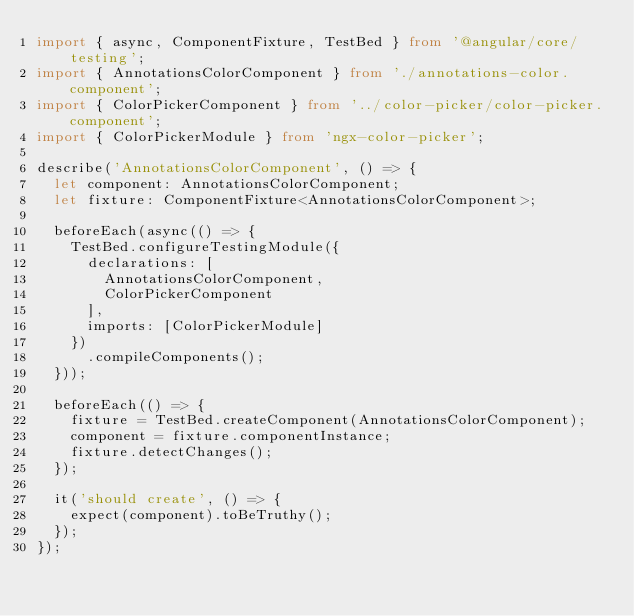<code> <loc_0><loc_0><loc_500><loc_500><_TypeScript_>import { async, ComponentFixture, TestBed } from '@angular/core/testing';
import { AnnotationsColorComponent } from './annotations-color.component';
import { ColorPickerComponent } from '../color-picker/color-picker.component';
import { ColorPickerModule } from 'ngx-color-picker';

describe('AnnotationsColorComponent', () => {
	let component: AnnotationsColorComponent;
	let fixture: ComponentFixture<AnnotationsColorComponent>;

	beforeEach(async(() => {
		TestBed.configureTestingModule({
			declarations: [
				AnnotationsColorComponent,
				ColorPickerComponent
			],
			imports: [ColorPickerModule]
		})
			.compileComponents();
	}));

	beforeEach(() => {
		fixture = TestBed.createComponent(AnnotationsColorComponent);
		component = fixture.componentInstance;
		fixture.detectChanges();
	});

	it('should create', () => {
		expect(component).toBeTruthy();
	});
});
</code> 